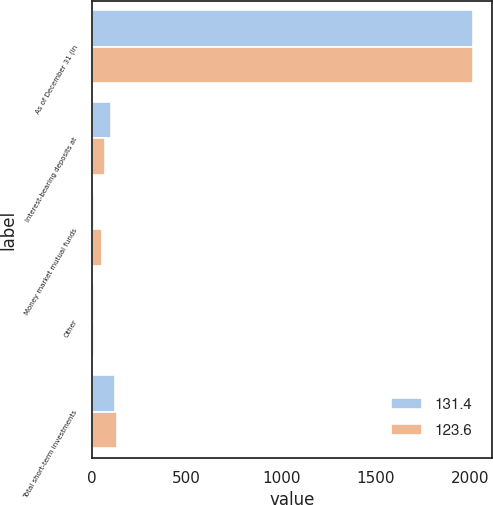Convert chart. <chart><loc_0><loc_0><loc_500><loc_500><stacked_bar_chart><ecel><fcel>As of December 31 (in<fcel>Interest-bearing deposits at<fcel>Money market mutual funds<fcel>Other<fcel>Total short-term investments<nl><fcel>131.4<fcel>2013<fcel>102.5<fcel>10.8<fcel>10.3<fcel>123.6<nl><fcel>123.6<fcel>2012<fcel>69.7<fcel>52.6<fcel>9.1<fcel>131.4<nl></chart> 